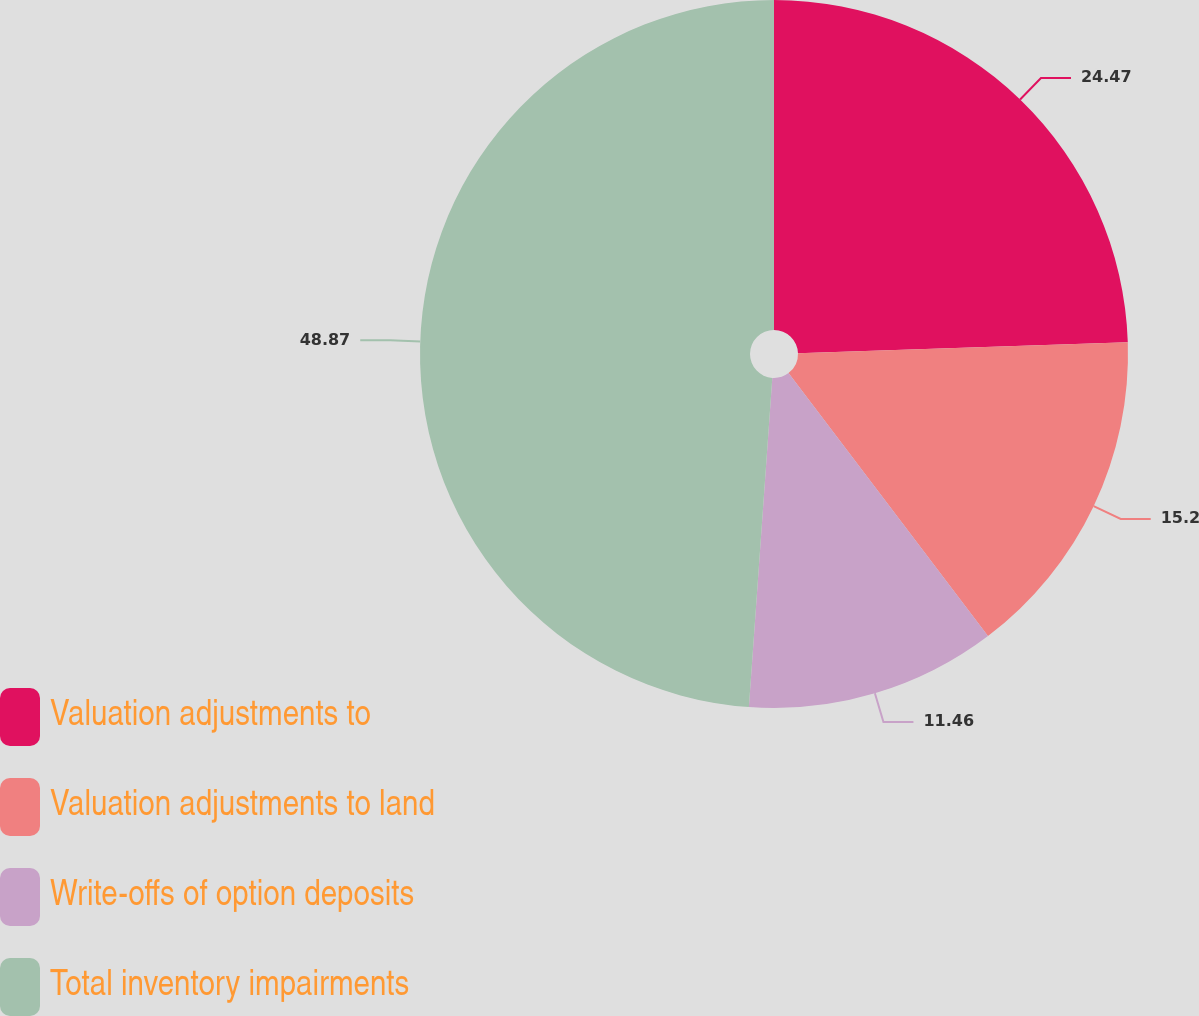Convert chart to OTSL. <chart><loc_0><loc_0><loc_500><loc_500><pie_chart><fcel>Valuation adjustments to<fcel>Valuation adjustments to land<fcel>Write-offs of option deposits<fcel>Total inventory impairments<nl><fcel>24.47%<fcel>15.2%<fcel>11.46%<fcel>48.87%<nl></chart> 